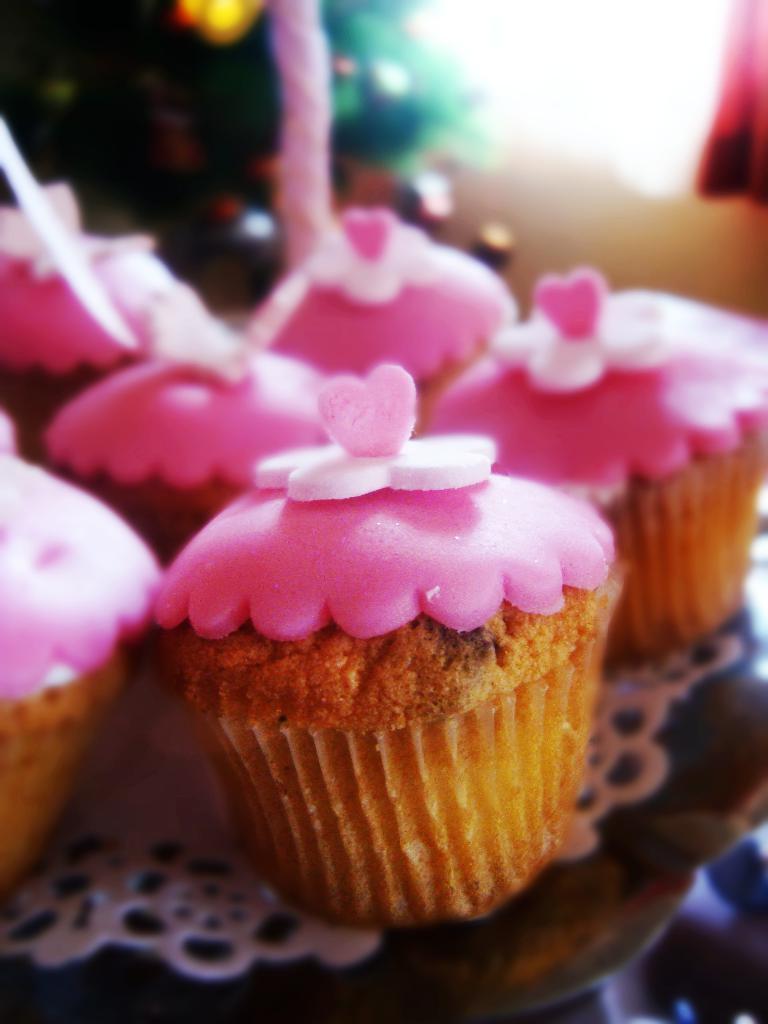Can you describe this image briefly? In this picture we can see there are cupcakes on an object. On the cupcakes there are candies. Behind the cupcakes there is the blurred background. 